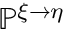<formula> <loc_0><loc_0><loc_500><loc_500>\mathbb { P } ^ { \xi \rightarrow \eta }</formula> 